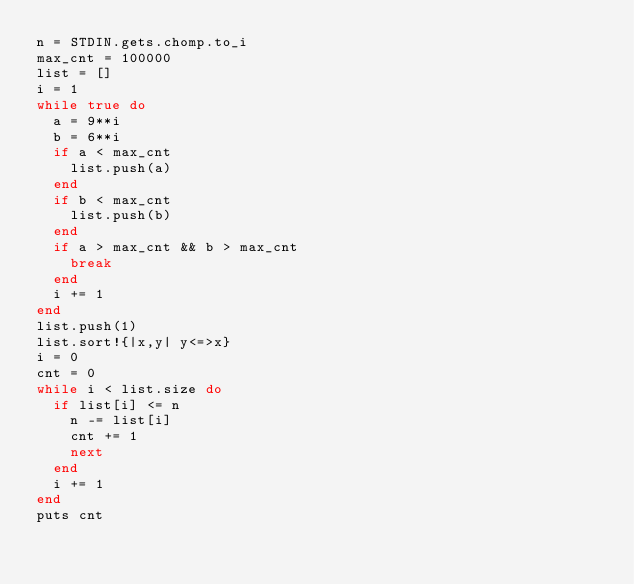Convert code to text. <code><loc_0><loc_0><loc_500><loc_500><_Ruby_>n = STDIN.gets.chomp.to_i
max_cnt = 100000
list = []
i = 1
while true do
  a = 9**i
  b = 6**i
  if a < max_cnt
    list.push(a)
  end
  if b < max_cnt
    list.push(b)
  end
  if a > max_cnt && b > max_cnt
    break
  end
  i += 1
end
list.push(1)
list.sort!{|x,y| y<=>x}
i = 0
cnt = 0
while i < list.size do
  if list[i] <= n
    n -= list[i]
    cnt += 1
    next
  end
  i += 1
end
puts cnt
</code> 